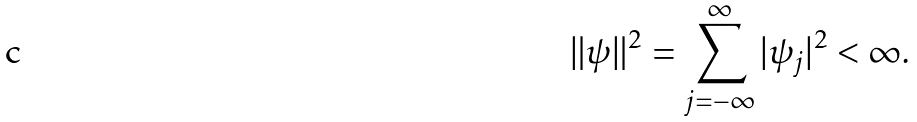<formula> <loc_0><loc_0><loc_500><loc_500>\| \psi \| ^ { 2 } = \sum _ { j = - \infty } ^ { \infty } | \psi _ { j } | ^ { 2 } < \infty .</formula> 